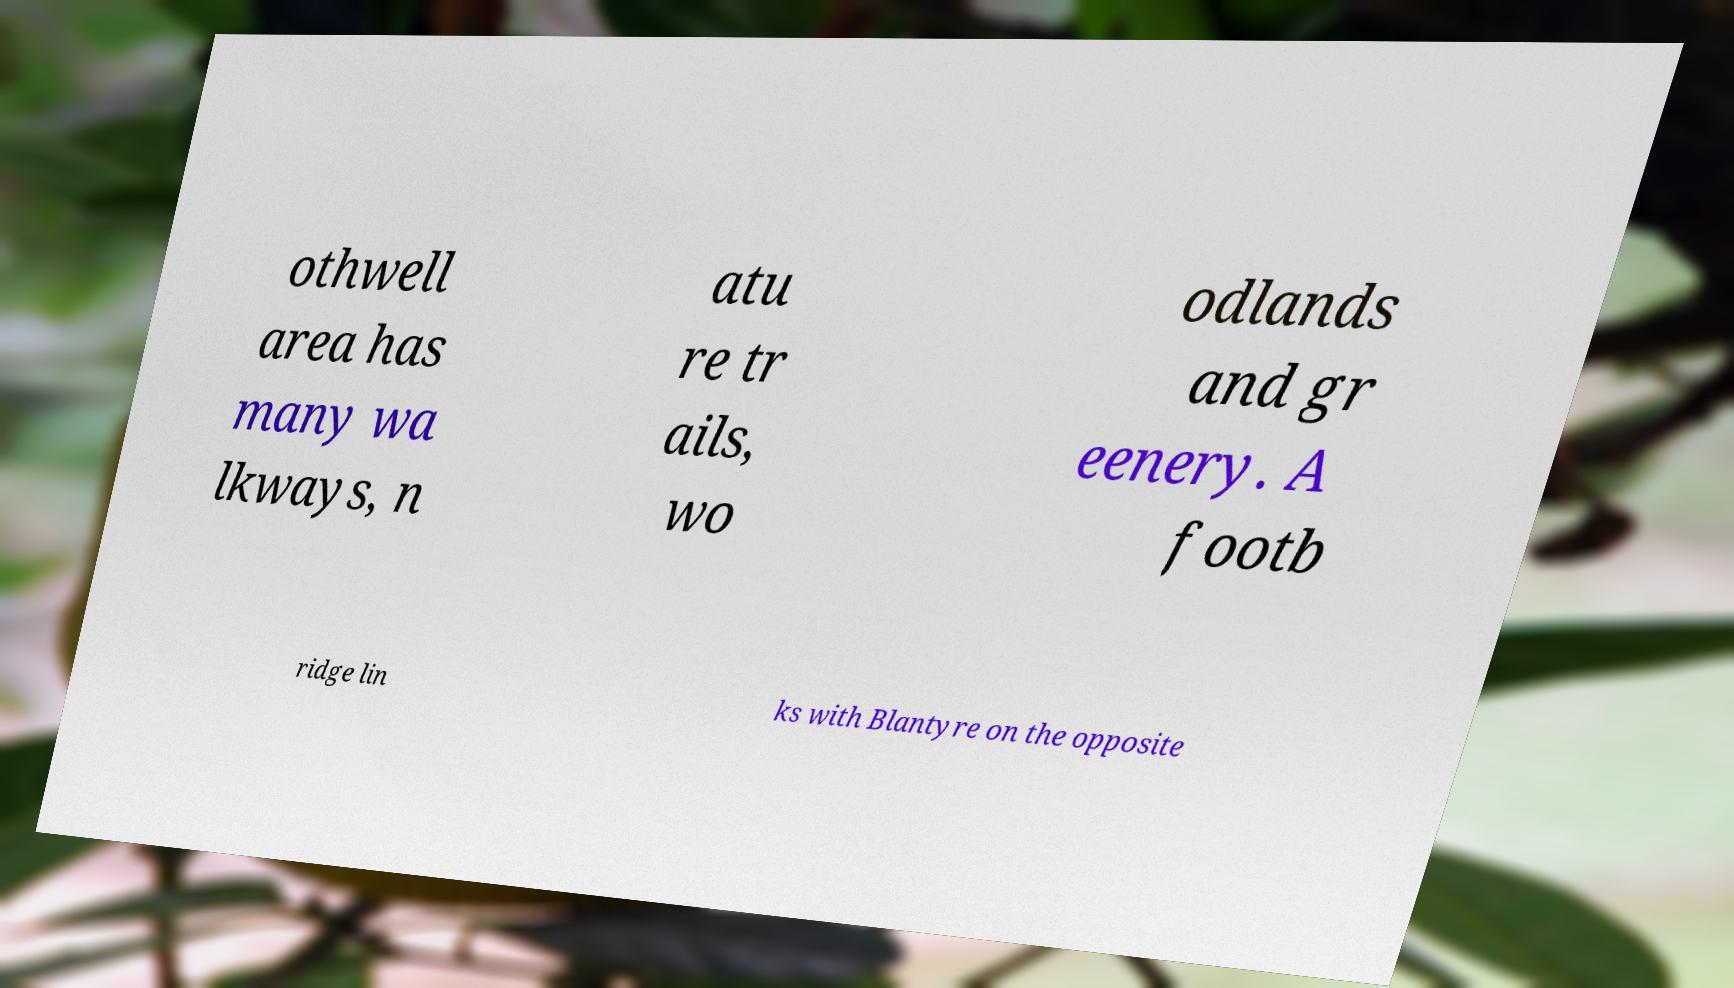For documentation purposes, I need the text within this image transcribed. Could you provide that? othwell area has many wa lkways, n atu re tr ails, wo odlands and gr eenery. A footb ridge lin ks with Blantyre on the opposite 